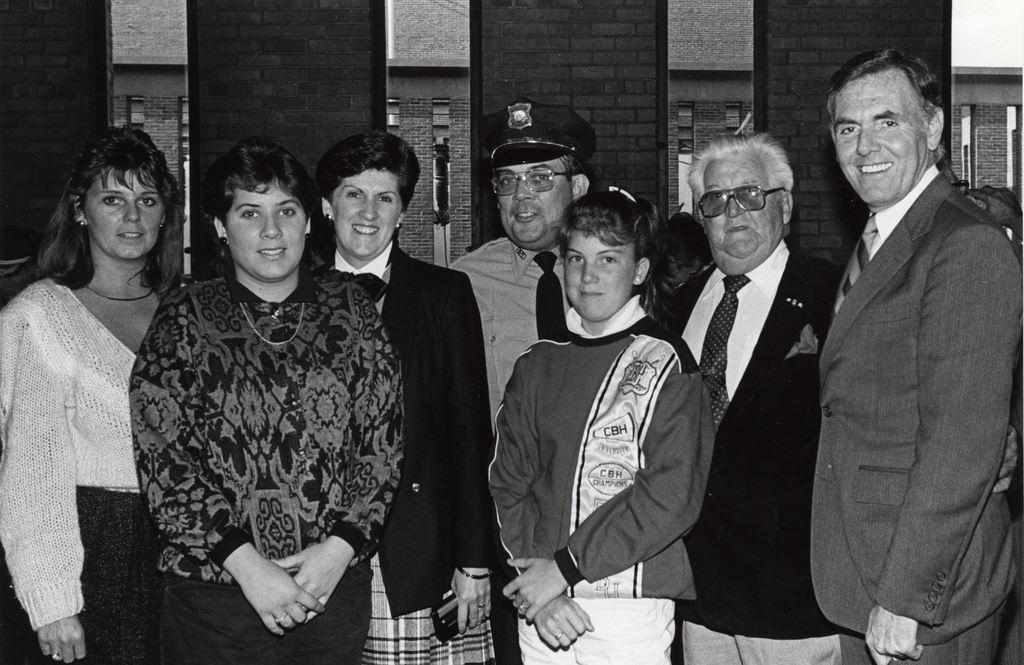How would you summarize this image in a sentence or two? In this picture there is a group of men and women standing in the front, smiling and giving a pose into the camera. Behind there is a brick panel wall. 